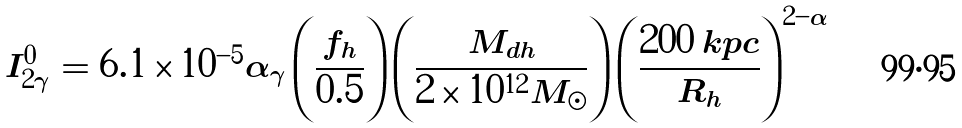Convert formula to latex. <formula><loc_0><loc_0><loc_500><loc_500>I _ { 2 \gamma } ^ { 0 } = 6 . 1 \times 1 0 ^ { - 5 } \alpha _ { \gamma } \left ( \frac { f _ { h } } { 0 . 5 } \right ) \left ( \frac { M _ { d h } } { 2 \times 1 0 ^ { 1 2 } M _ { \odot } } \right ) \left ( \frac { 2 0 0 \, k p c } { R _ { h } } \right ) ^ { 2 - \alpha }</formula> 